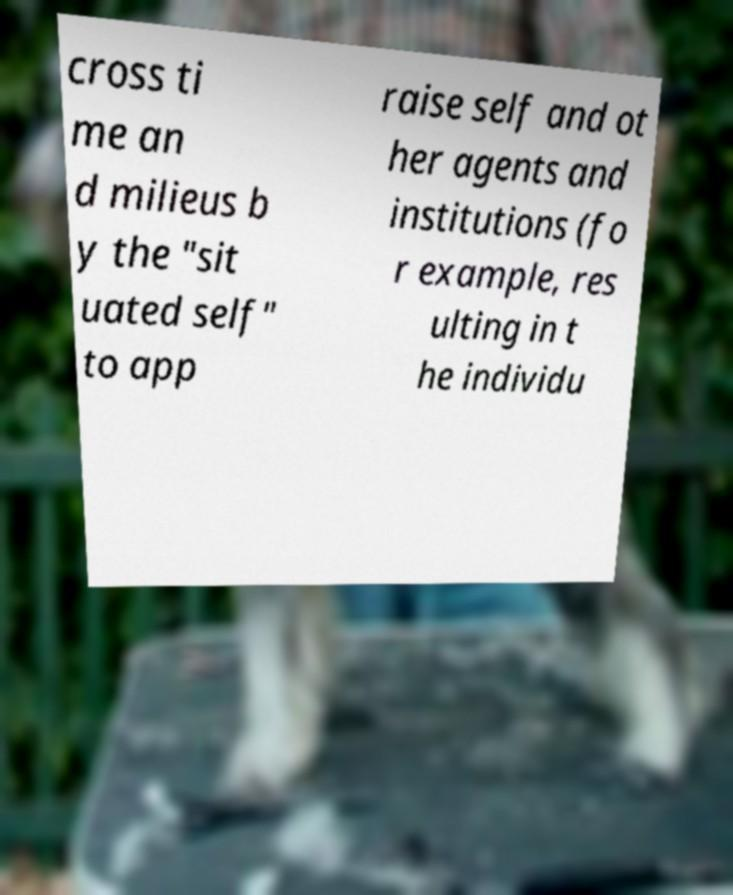Can you read and provide the text displayed in the image?This photo seems to have some interesting text. Can you extract and type it out for me? cross ti me an d milieus b y the "sit uated self" to app raise self and ot her agents and institutions (fo r example, res ulting in t he individu 